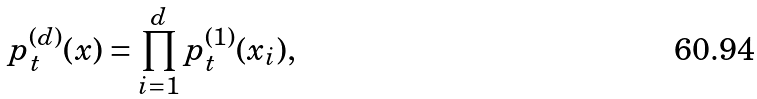Convert formula to latex. <formula><loc_0><loc_0><loc_500><loc_500>p ^ { ( d ) } _ { t } ( x ) = \prod _ { i = 1 } ^ { d } p ^ { ( 1 ) } _ { t } ( x _ { i } ) ,</formula> 